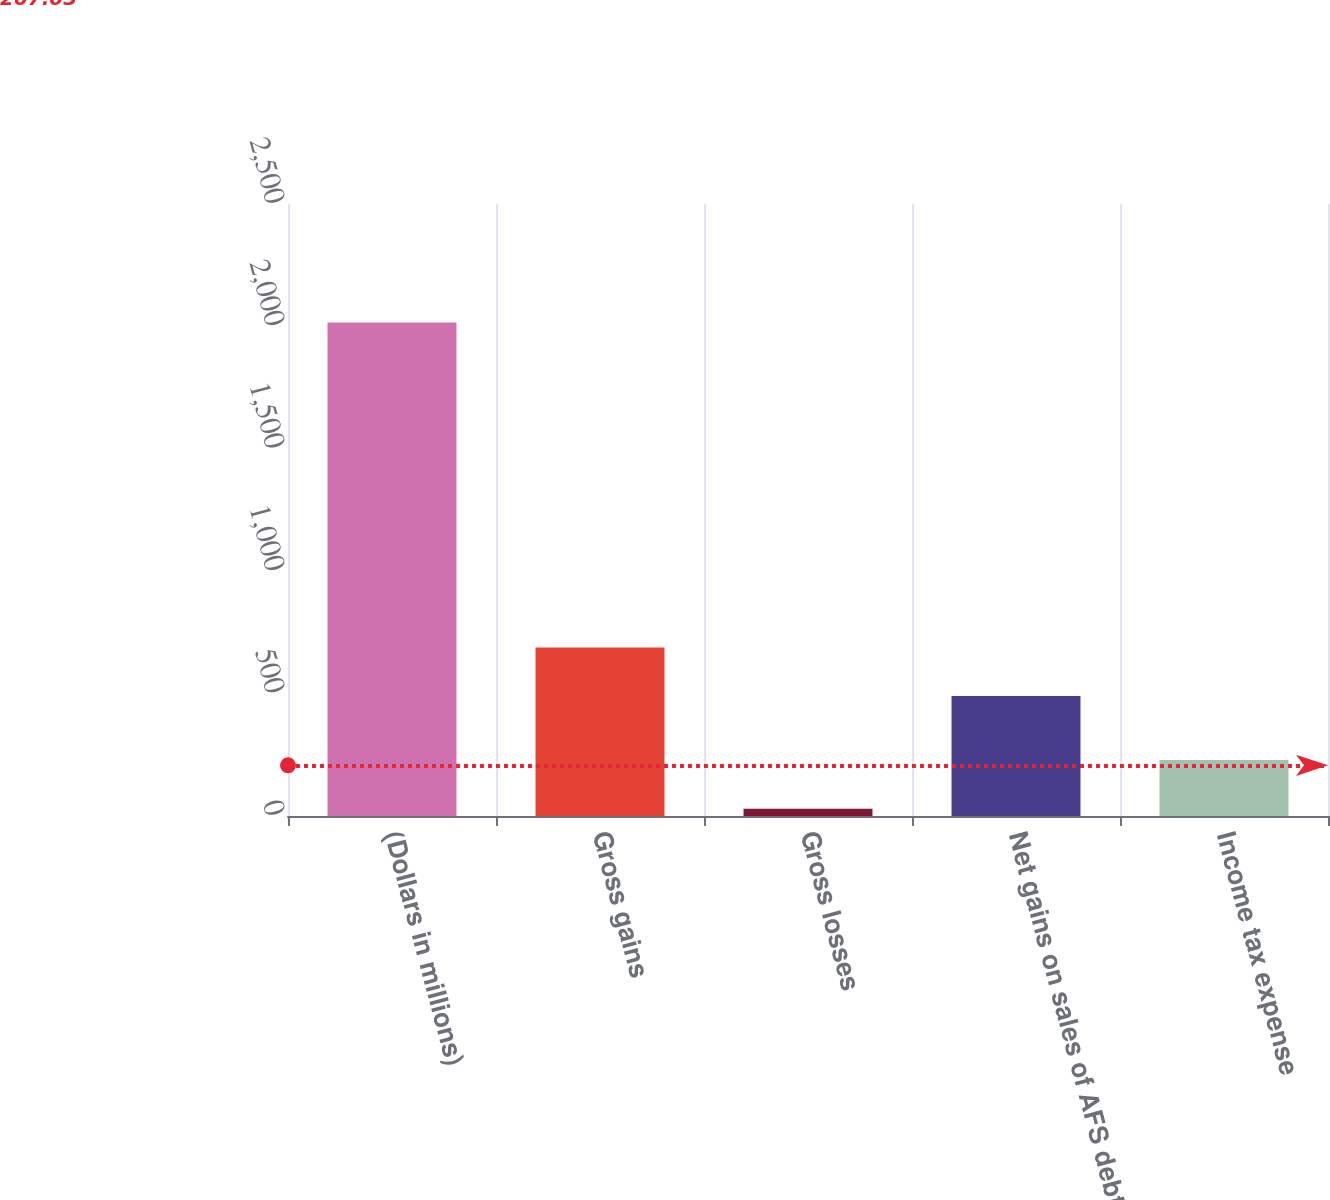Convert chart to OTSL. <chart><loc_0><loc_0><loc_500><loc_500><bar_chart><fcel>(Dollars in millions)<fcel>Gross gains<fcel>Gross losses<fcel>Net gains on sales of AFS debt<fcel>Income tax expense<nl><fcel>2016<fcel>688.6<fcel>30<fcel>490<fcel>228.6<nl></chart> 